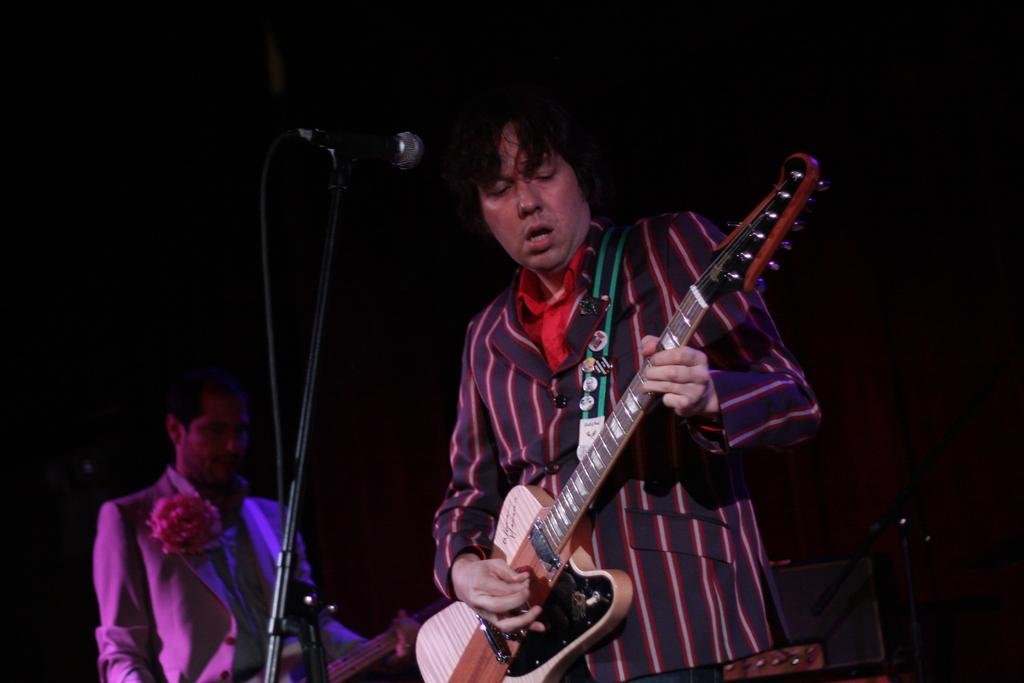How many people are in the image? There are two men in the image. What are the men doing in the image? The men are standing and holding guitars. What are the men wearing in the image? Both men are wearing blazers. What object is in front of one of the men? There is a microphone in front of one of the men. What type of thrill can be seen in the image? There is no reference to a thrill in the image; it features two men standing with guitars and a microphone. 